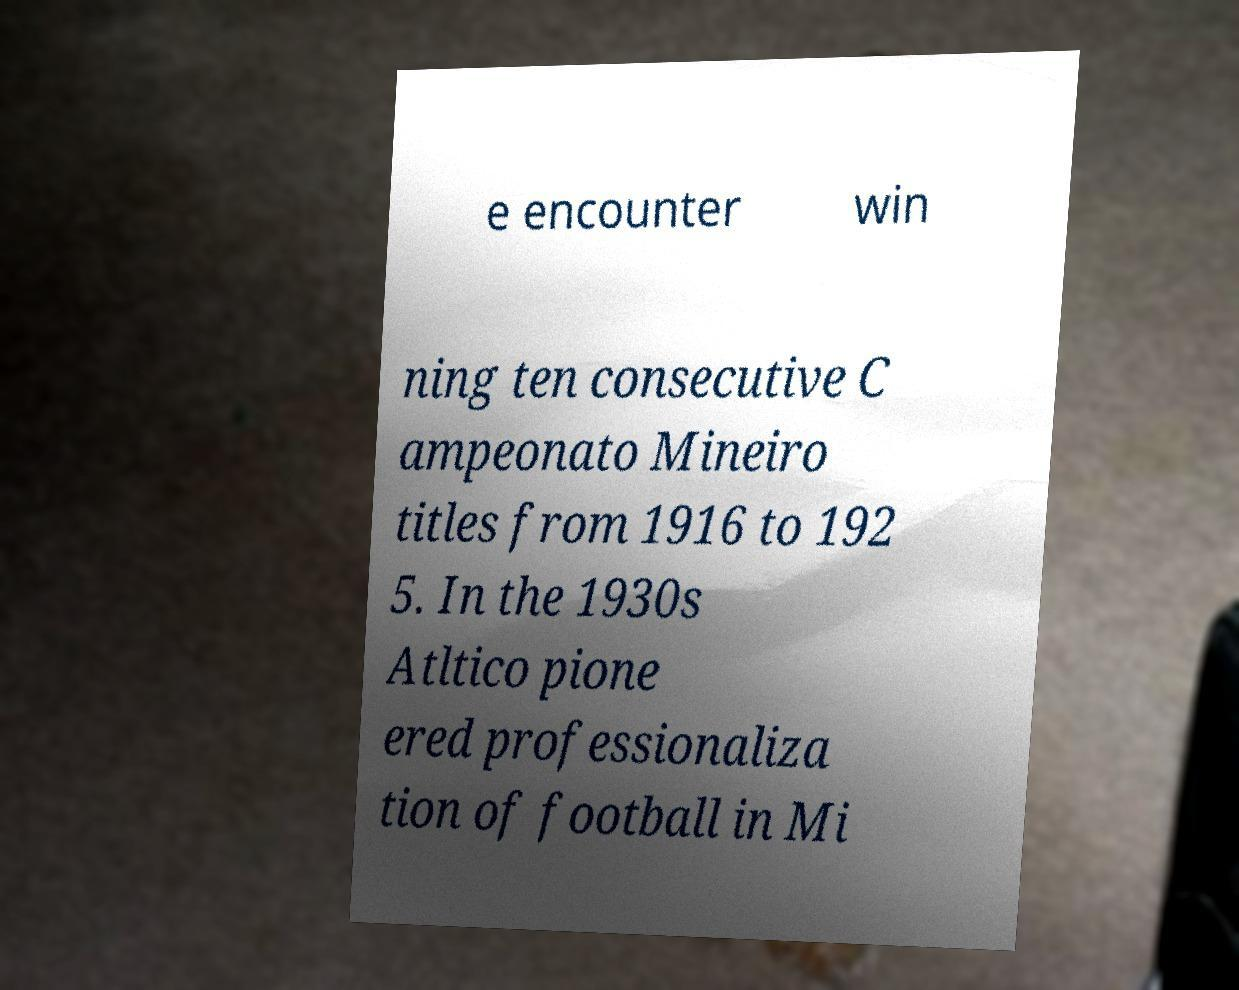What messages or text are displayed in this image? I need them in a readable, typed format. e encounter win ning ten consecutive C ampeonato Mineiro titles from 1916 to 192 5. In the 1930s Atltico pione ered professionaliza tion of football in Mi 